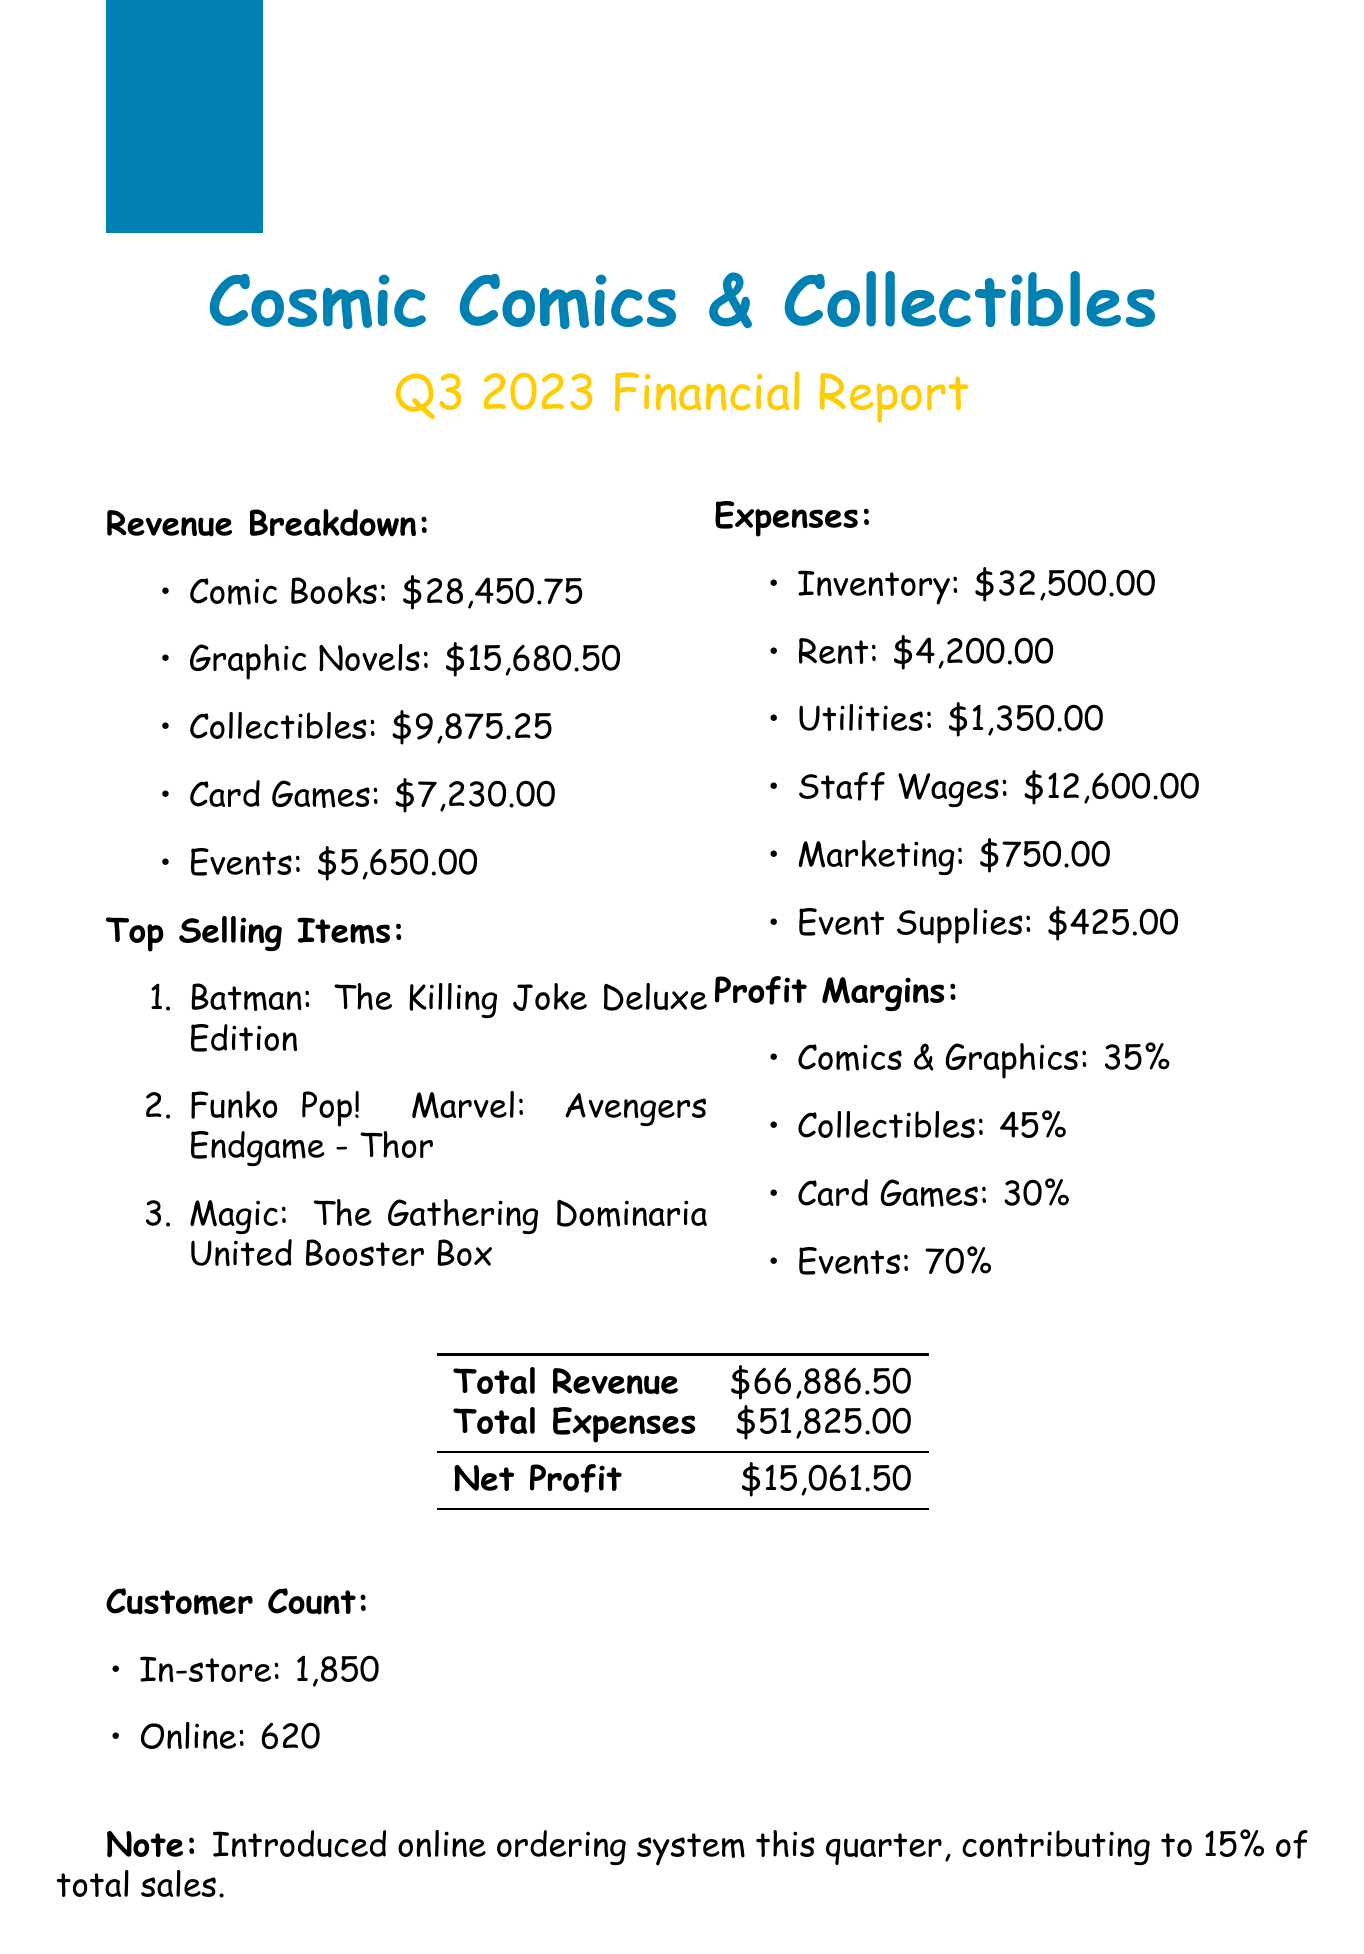What is the total revenue? The total revenue is provided in the summary section of the document, calculated from all revenue sources, which totals $66,886.50.
Answer: $66,886.50 What is the total profit for Q3 2023? The total profit is found by subtracting total expenses from total revenue, resulting in a profit of $15,061.50.
Answer: $15,061.50 How much was made from comic signings? The revenue from comic signings is specifically listed under events in the revenue section, which amounts to $1,200.00.
Answer: $1,200.00 What are the top selling items? The document lists the top three selling items in order, which are Batman: The Killing Joke Deluxe Edition, Funko Pop! Marvel: Avengers Endgame - Thor, and Magic: The Gathering Dominaria United Booster Box.
Answer: Batman: The Killing Joke Deluxe Edition What was the total expense for staff wages? The total expense for staff wages is given directly in the expenses section of the document, specifically noted as $12,600.00.
Answer: $12,600.00 What percentage of the revenue came from online sales? The note in the document states that online sales accounted for 15% of total sales, which provides a direct insight into online sales contribution.
Answer: 15% Which category has the highest profit margin? The profit margins listed indicate that the events category has the highest margin at 70%, making it the best-performing area for profitability.
Answer: 70% How many customers visited the store in Q3 2023? The document specifies the in-store customer count as 1,850, which represents the number of visitors during the quarter.
Answer: 1,850 What was the expense for marketing? The expenses section explicitly mentions the amount spent on marketing, which is $750.00.
Answer: $750.00 